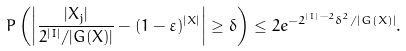Convert formula to latex. <formula><loc_0><loc_0><loc_500><loc_500>P \left ( \left | \frac { | X _ { j } | } { 2 ^ { | I | } / | G ( X ) | } - ( 1 - \varepsilon ) ^ { | X | } \right | \geq \delta \right ) \leq 2 e ^ { - 2 ^ { | I | - 2 } \delta ^ { 2 } / | G ( X ) | } .</formula> 